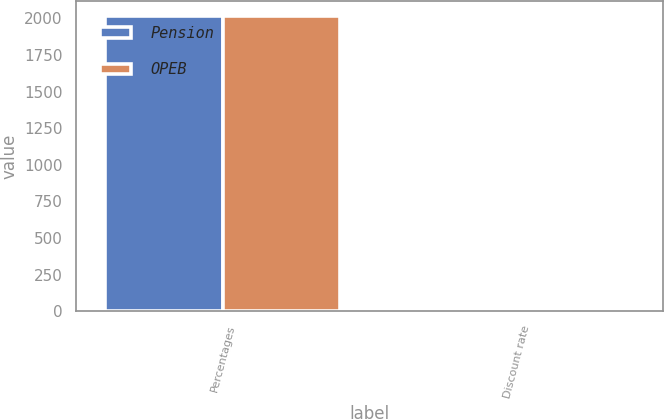Convert chart to OTSL. <chart><loc_0><loc_0><loc_500><loc_500><stacked_bar_chart><ecel><fcel>Percentages<fcel>Discount rate<nl><fcel>Pension<fcel>2014<fcel>3.94<nl><fcel>OPEB<fcel>2014<fcel>3.74<nl></chart> 